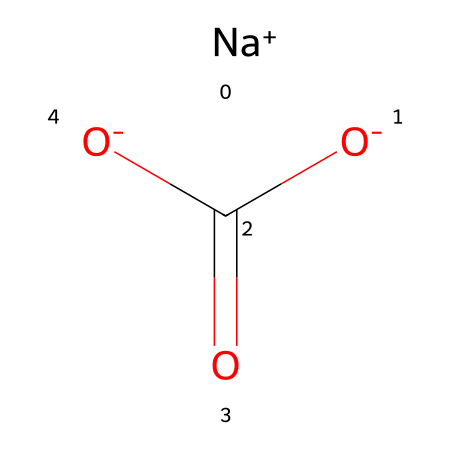What is the IUPAC name of the compound represented by the SMILES? The SMILES representation indicates the structure of sodium bicarbonate, which can be named using the IUPAC nomenclature as sodium hydrogen carbonate.
Answer: sodium hydrogen carbonate How many carbon atoms are in this compound? The SMILES shows one carbon atom, which is represented as 'C' in the structure.
Answer: one How many oxygen atoms are bonded to the carbon atom? In the SMILES representation, the carbon atom is bonded to three oxygen atoms: two as part of the carboxylate groups and one as a hydrogen carbonate.
Answer: three What type of chemical reaction can sodium bicarbonate undergo when heated? Sodium bicarbonate can decompose upon heating, producing sodium carbonate, carbon dioxide, and water. This reaction is well-known in chemistry.
Answer: decomposition Is sodium bicarbonate considered a base or acid? Sodium bicarbonate functions as a weak base because it can neutralize acids upon reaction, showing basic properties.
Answer: base Which part of the compound carries a negative charge? The SMILES structure indicates that one of the oxygen atoms has a negative charge (O-) associated with it, indicating that the bicarbonate ion carries this charge.
Answer: O- What is the main use of sodium bicarbonate in cooking? Sodium bicarbonate acts as a leavening agent in baking, helping dough to rise due to the production of carbon dioxide when it reacts with an acid.
Answer: leavening agent 